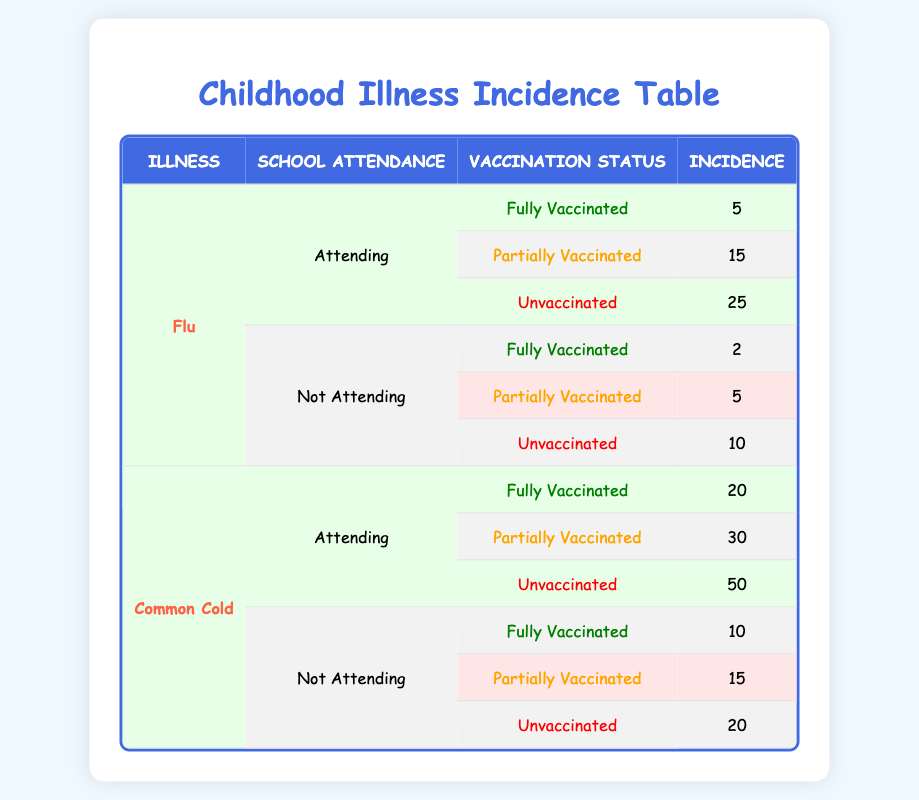What is the incidence of flu for children who are fully vaccinated and attending school? According to the table, for children who are fully vaccinated and attending school, the incidence of flu is 5.
Answer: 5 What is the total incidence of common cold for children who are unvaccinated? From the table, we see that the incidence of common cold for unvaccinated children attending school is 50, and for those not attending, it is 20. Summing these gives us 50 + 20 = 70.
Answer: 70 Is the incidence of flu higher for unvaccinated children attending school compared to those not attending? The incidence of flu for unvaccinated children who are attending school is 25, while for those not attending, it is 10. Since 25 is greater than 10, the incidence of flu is higher for attending children.
Answer: Yes What is the average incidence of flu for children who are partially vaccinated? For partially vaccinated children, the incidence of flu for those attending school is 15, and for those not attending, it is 5. To find the average, we sum these values: 15 + 5 = 20 and divide by the number of data points, which is 2. Therefore, the average incidence is 20 / 2 = 10.
Answer: 10 How many more cases of common cold are reported among unvaccinated children attending school compared to those who are fully vaccinated and not attending? The table indicates that unvaccinated children attending school have an incidence of 50 for common cold, while fully vaccinated children who are not attending have an incidence of 10. To find the difference, we subtract: 50 - 10 = 40.
Answer: 40 What is the total incidence of flu for children who are not attending school? The incidence of flu for children not attending school is 2 (fully vaccinated) + 5 (partially vaccinated) + 10 (unvaccinated) = 17, resulting in a total incidence of 17.
Answer: 17 Is there a higher incidence rate of common cold among children who are attending school and partially vaccinated than those who are fully vaccinated and not attending? For attending children who are partially vaccinated, the incidence for common cold is 30. For fully vaccinated children who are not attending, the incidence is 10. Since 30 is greater than 10, the incidence rate is higher for partially vaccinated children attending school.
Answer: Yes What is the total incidence of flu and common cold for children who are fully vaccinated? Adding the incidence for fully vaccinated children: flu incidence is 5 (attending) + 2 (not attending) = 7, and common cold is 20 (attending) + 10 (not attending) = 30. The total is 7 + 30 = 37.
Answer: 37 